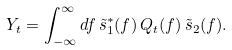Convert formula to latex. <formula><loc_0><loc_0><loc_500><loc_500>Y _ { t } = \int _ { - \infty } ^ { \infty } d f \, \tilde { s } _ { 1 } ^ { * } ( f ) \, Q _ { t } ( f ) \, \tilde { s } _ { 2 } ( f ) .</formula> 